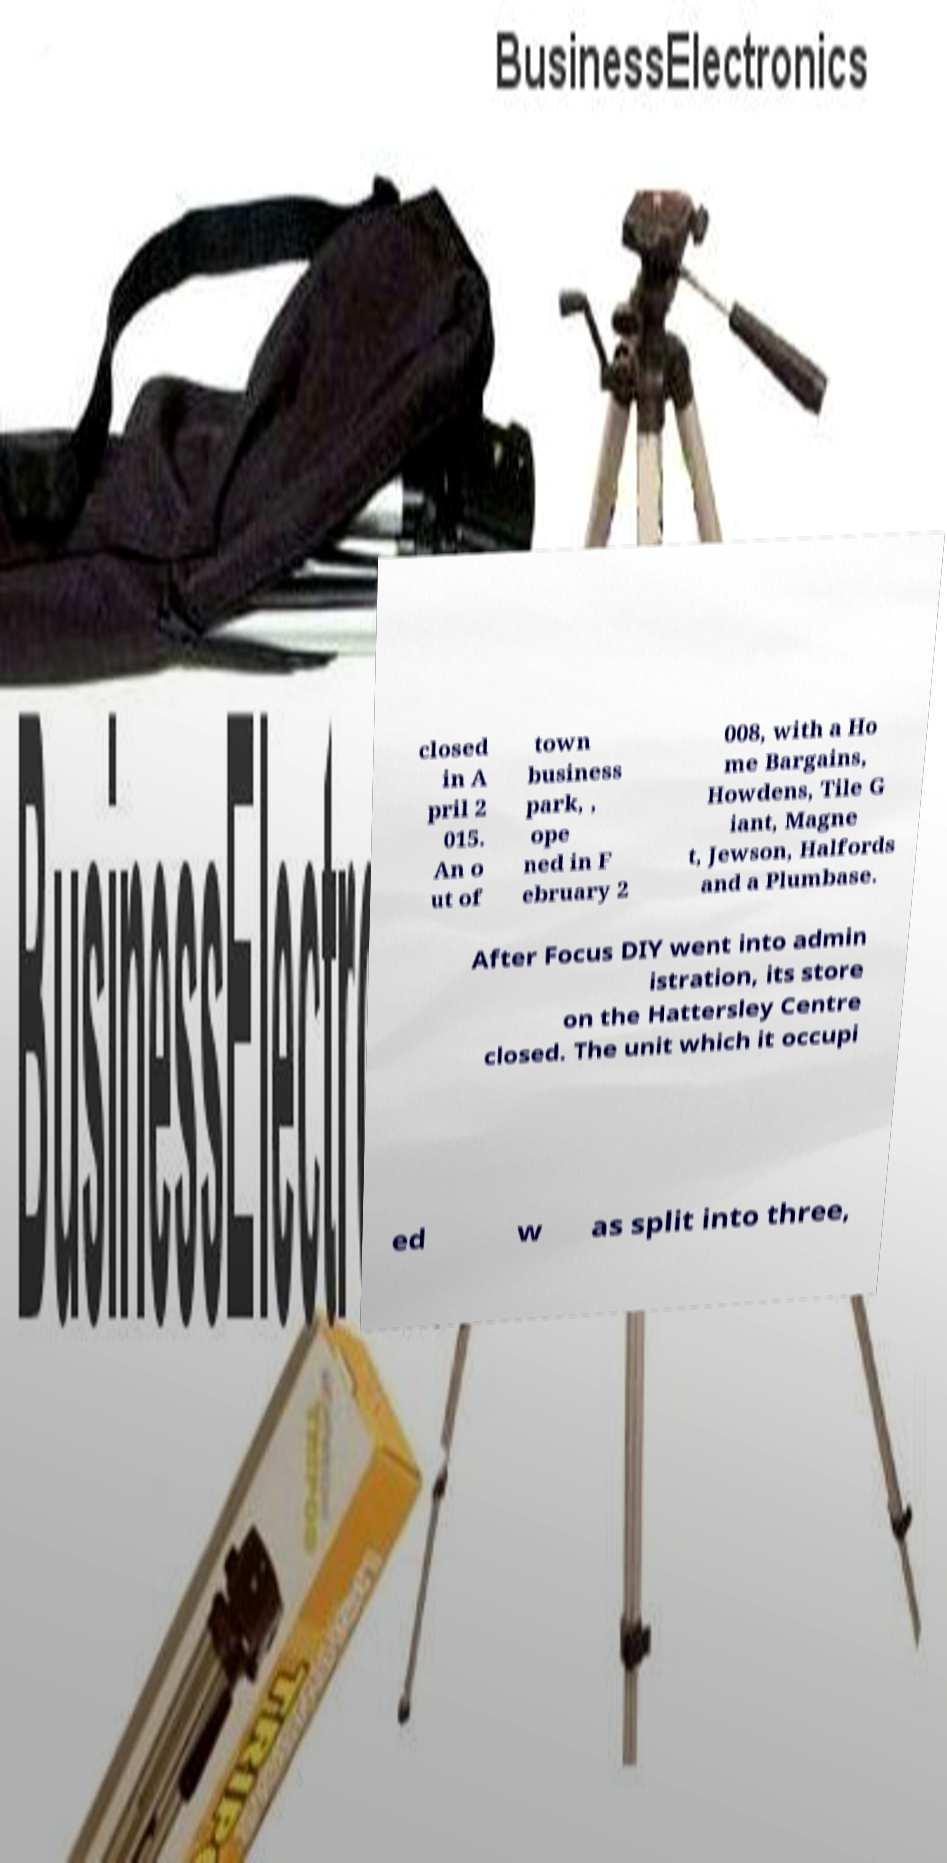Please identify and transcribe the text found in this image. closed in A pril 2 015. An o ut of town business park, , ope ned in F ebruary 2 008, with a Ho me Bargains, Howdens, Tile G iant, Magne t, Jewson, Halfords and a Plumbase. After Focus DIY went into admin istration, its store on the Hattersley Centre closed. The unit which it occupi ed w as split into three, 